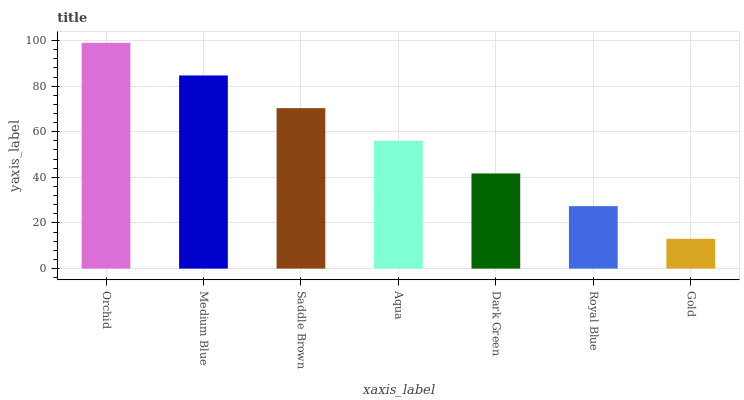Is Medium Blue the minimum?
Answer yes or no. No. Is Medium Blue the maximum?
Answer yes or no. No. Is Orchid greater than Medium Blue?
Answer yes or no. Yes. Is Medium Blue less than Orchid?
Answer yes or no. Yes. Is Medium Blue greater than Orchid?
Answer yes or no. No. Is Orchid less than Medium Blue?
Answer yes or no. No. Is Aqua the high median?
Answer yes or no. Yes. Is Aqua the low median?
Answer yes or no. Yes. Is Saddle Brown the high median?
Answer yes or no. No. Is Royal Blue the low median?
Answer yes or no. No. 